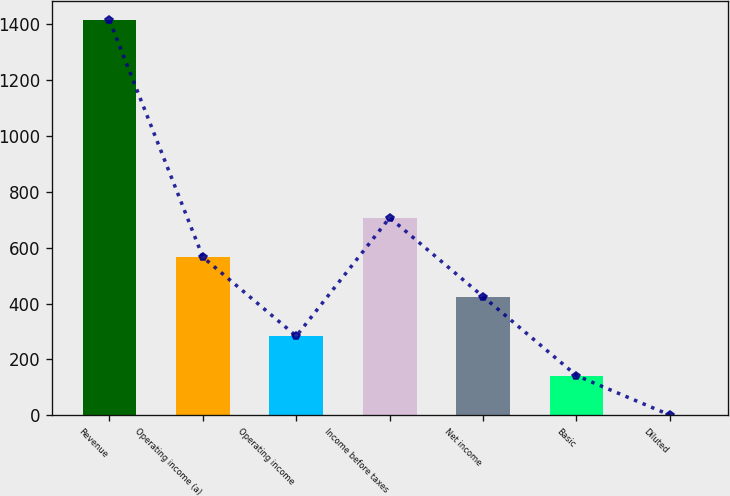<chart> <loc_0><loc_0><loc_500><loc_500><bar_chart><fcel>Revenue<fcel>Operating income (a)<fcel>Operating income<fcel>Income before taxes<fcel>Net income<fcel>Basic<fcel>Diluted<nl><fcel>1414.2<fcel>566.27<fcel>283.63<fcel>707.59<fcel>424.95<fcel>142.31<fcel>0.99<nl></chart> 